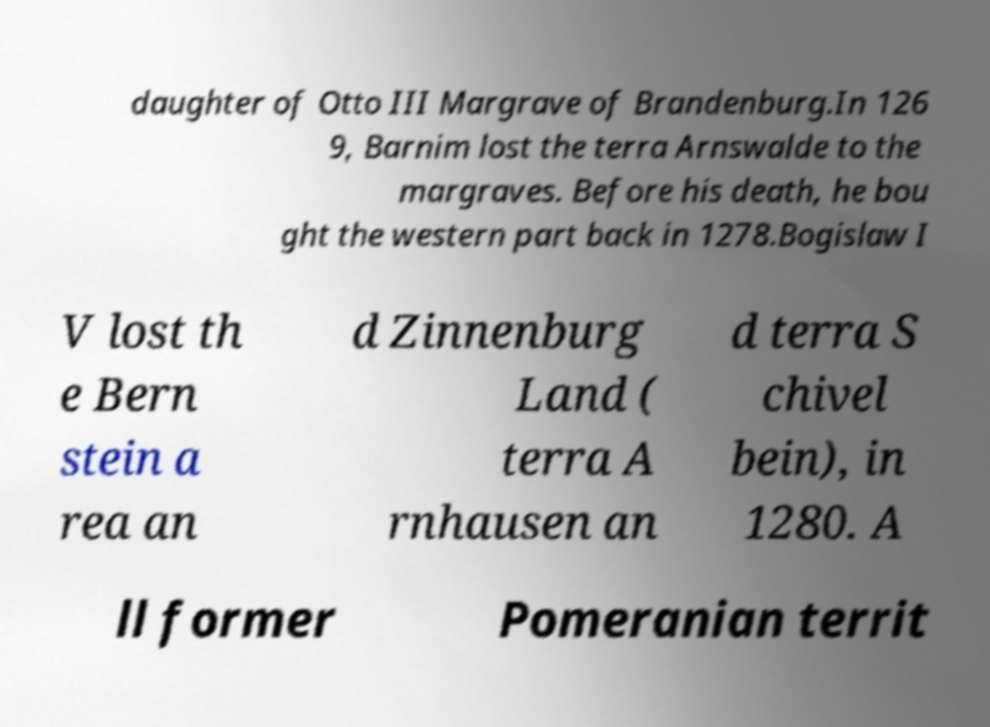There's text embedded in this image that I need extracted. Can you transcribe it verbatim? daughter of Otto III Margrave of Brandenburg.In 126 9, Barnim lost the terra Arnswalde to the margraves. Before his death, he bou ght the western part back in 1278.Bogislaw I V lost th e Bern stein a rea an d Zinnenburg Land ( terra A rnhausen an d terra S chivel bein), in 1280. A ll former Pomeranian territ 